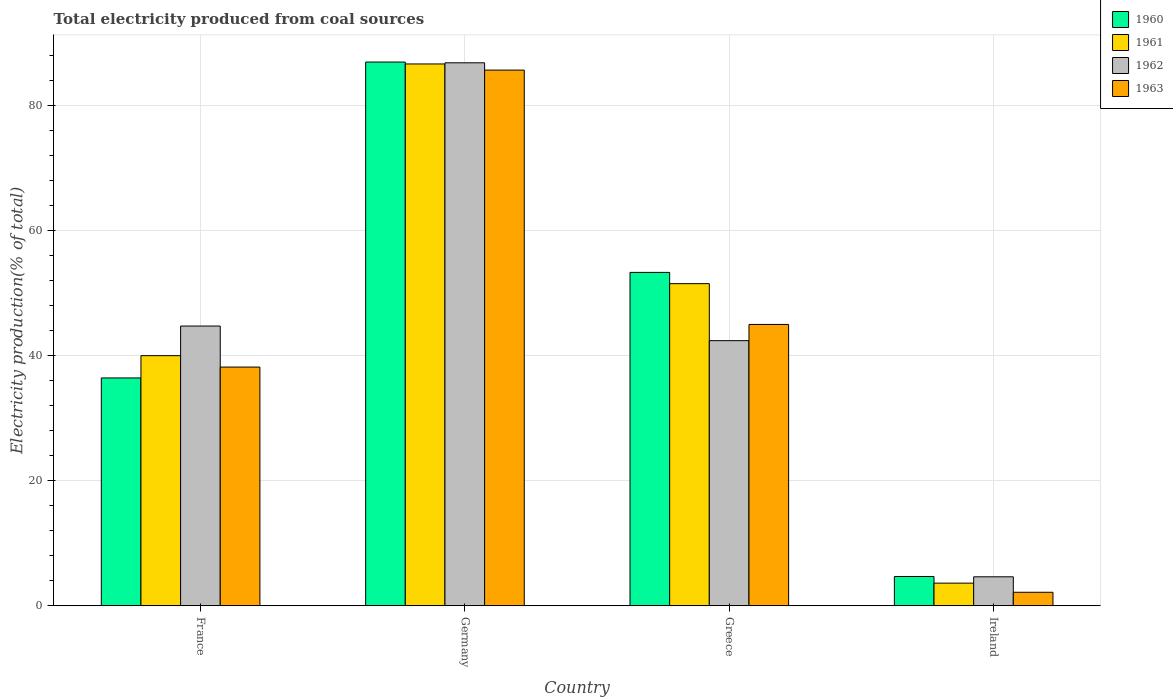How many different coloured bars are there?
Provide a succinct answer. 4. Are the number of bars per tick equal to the number of legend labels?
Give a very brief answer. Yes. Are the number of bars on each tick of the X-axis equal?
Provide a short and direct response. Yes. How many bars are there on the 3rd tick from the left?
Give a very brief answer. 4. What is the label of the 1st group of bars from the left?
Provide a short and direct response. France. In how many cases, is the number of bars for a given country not equal to the number of legend labels?
Ensure brevity in your answer.  0. What is the total electricity produced in 1960 in Germany?
Your answer should be compact. 87.03. Across all countries, what is the maximum total electricity produced in 1960?
Offer a terse response. 87.03. Across all countries, what is the minimum total electricity produced in 1960?
Make the answer very short. 4.69. In which country was the total electricity produced in 1962 minimum?
Provide a succinct answer. Ireland. What is the total total electricity produced in 1963 in the graph?
Ensure brevity in your answer.  171.15. What is the difference between the total electricity produced in 1962 in Greece and that in Ireland?
Offer a very short reply. 37.8. What is the difference between the total electricity produced in 1961 in Greece and the total electricity produced in 1960 in France?
Keep it short and to the point. 15.09. What is the average total electricity produced in 1961 per country?
Offer a very short reply. 45.49. What is the difference between the total electricity produced of/in 1961 and total electricity produced of/in 1963 in France?
Your response must be concise. 1.82. What is the ratio of the total electricity produced in 1961 in Germany to that in Greece?
Make the answer very short. 1.68. Is the total electricity produced in 1961 in Greece less than that in Ireland?
Ensure brevity in your answer.  No. What is the difference between the highest and the second highest total electricity produced in 1961?
Your answer should be very brief. -11.53. What is the difference between the highest and the lowest total electricity produced in 1961?
Your answer should be very brief. 83.1. Is the sum of the total electricity produced in 1960 in Greece and Ireland greater than the maximum total electricity produced in 1963 across all countries?
Ensure brevity in your answer.  No. Is it the case that in every country, the sum of the total electricity produced in 1961 and total electricity produced in 1963 is greater than the sum of total electricity produced in 1962 and total electricity produced in 1960?
Your answer should be very brief. No. What is the difference between two consecutive major ticks on the Y-axis?
Your answer should be compact. 20. Are the values on the major ticks of Y-axis written in scientific E-notation?
Your response must be concise. No. Where does the legend appear in the graph?
Ensure brevity in your answer.  Top right. How many legend labels are there?
Provide a short and direct response. 4. What is the title of the graph?
Your answer should be very brief. Total electricity produced from coal sources. Does "2012" appear as one of the legend labels in the graph?
Keep it short and to the point. No. What is the Electricity production(% of total) of 1960 in France?
Give a very brief answer. 36.47. What is the Electricity production(% of total) of 1961 in France?
Keep it short and to the point. 40.03. What is the Electricity production(% of total) in 1962 in France?
Provide a short and direct response. 44.78. What is the Electricity production(% of total) of 1963 in France?
Your answer should be very brief. 38.21. What is the Electricity production(% of total) of 1960 in Germany?
Give a very brief answer. 87.03. What is the Electricity production(% of total) of 1961 in Germany?
Provide a short and direct response. 86.73. What is the Electricity production(% of total) of 1962 in Germany?
Your answer should be compact. 86.91. What is the Electricity production(% of total) in 1963 in Germany?
Offer a terse response. 85.74. What is the Electricity production(% of total) of 1960 in Greece?
Ensure brevity in your answer.  53.36. What is the Electricity production(% of total) of 1961 in Greece?
Provide a succinct answer. 51.56. What is the Electricity production(% of total) of 1962 in Greece?
Give a very brief answer. 42.44. What is the Electricity production(% of total) in 1963 in Greece?
Ensure brevity in your answer.  45.03. What is the Electricity production(% of total) in 1960 in Ireland?
Offer a very short reply. 4.69. What is the Electricity production(% of total) in 1961 in Ireland?
Offer a terse response. 3.63. What is the Electricity production(% of total) of 1962 in Ireland?
Provide a succinct answer. 4.64. What is the Electricity production(% of total) in 1963 in Ireland?
Ensure brevity in your answer.  2.16. Across all countries, what is the maximum Electricity production(% of total) of 1960?
Offer a terse response. 87.03. Across all countries, what is the maximum Electricity production(% of total) in 1961?
Your response must be concise. 86.73. Across all countries, what is the maximum Electricity production(% of total) in 1962?
Provide a short and direct response. 86.91. Across all countries, what is the maximum Electricity production(% of total) of 1963?
Make the answer very short. 85.74. Across all countries, what is the minimum Electricity production(% of total) of 1960?
Make the answer very short. 4.69. Across all countries, what is the minimum Electricity production(% of total) in 1961?
Offer a terse response. 3.63. Across all countries, what is the minimum Electricity production(% of total) of 1962?
Your answer should be very brief. 4.64. Across all countries, what is the minimum Electricity production(% of total) in 1963?
Ensure brevity in your answer.  2.16. What is the total Electricity production(% of total) in 1960 in the graph?
Your response must be concise. 181.55. What is the total Electricity production(% of total) of 1961 in the graph?
Your answer should be very brief. 181.95. What is the total Electricity production(% of total) of 1962 in the graph?
Your answer should be compact. 178.77. What is the total Electricity production(% of total) in 1963 in the graph?
Offer a very short reply. 171.15. What is the difference between the Electricity production(% of total) of 1960 in France and that in Germany?
Ensure brevity in your answer.  -50.56. What is the difference between the Electricity production(% of total) of 1961 in France and that in Germany?
Your response must be concise. -46.69. What is the difference between the Electricity production(% of total) in 1962 in France and that in Germany?
Offer a very short reply. -42.13. What is the difference between the Electricity production(% of total) of 1963 in France and that in Germany?
Give a very brief answer. -47.53. What is the difference between the Electricity production(% of total) of 1960 in France and that in Greece?
Offer a terse response. -16.89. What is the difference between the Electricity production(% of total) of 1961 in France and that in Greece?
Provide a short and direct response. -11.53. What is the difference between the Electricity production(% of total) in 1962 in France and that in Greece?
Offer a terse response. 2.34. What is the difference between the Electricity production(% of total) of 1963 in France and that in Greece?
Offer a terse response. -6.82. What is the difference between the Electricity production(% of total) of 1960 in France and that in Ireland?
Offer a terse response. 31.78. What is the difference between the Electricity production(% of total) of 1961 in France and that in Ireland?
Your response must be concise. 36.41. What is the difference between the Electricity production(% of total) of 1962 in France and that in Ireland?
Your answer should be compact. 40.14. What is the difference between the Electricity production(% of total) in 1963 in France and that in Ireland?
Provide a succinct answer. 36.05. What is the difference between the Electricity production(% of total) in 1960 in Germany and that in Greece?
Your response must be concise. 33.67. What is the difference between the Electricity production(% of total) in 1961 in Germany and that in Greece?
Keep it short and to the point. 35.16. What is the difference between the Electricity production(% of total) of 1962 in Germany and that in Greece?
Offer a terse response. 44.47. What is the difference between the Electricity production(% of total) in 1963 in Germany and that in Greece?
Offer a very short reply. 40.71. What is the difference between the Electricity production(% of total) of 1960 in Germany and that in Ireland?
Offer a very short reply. 82.34. What is the difference between the Electricity production(% of total) of 1961 in Germany and that in Ireland?
Keep it short and to the point. 83.1. What is the difference between the Electricity production(% of total) in 1962 in Germany and that in Ireland?
Ensure brevity in your answer.  82.27. What is the difference between the Electricity production(% of total) in 1963 in Germany and that in Ireland?
Give a very brief answer. 83.58. What is the difference between the Electricity production(% of total) in 1960 in Greece and that in Ireland?
Your response must be concise. 48.68. What is the difference between the Electricity production(% of total) of 1961 in Greece and that in Ireland?
Provide a succinct answer. 47.93. What is the difference between the Electricity production(% of total) of 1962 in Greece and that in Ireland?
Give a very brief answer. 37.8. What is the difference between the Electricity production(% of total) in 1963 in Greece and that in Ireland?
Provide a short and direct response. 42.87. What is the difference between the Electricity production(% of total) in 1960 in France and the Electricity production(% of total) in 1961 in Germany?
Offer a terse response. -50.26. What is the difference between the Electricity production(% of total) of 1960 in France and the Electricity production(% of total) of 1962 in Germany?
Keep it short and to the point. -50.44. What is the difference between the Electricity production(% of total) of 1960 in France and the Electricity production(% of total) of 1963 in Germany?
Offer a very short reply. -49.27. What is the difference between the Electricity production(% of total) of 1961 in France and the Electricity production(% of total) of 1962 in Germany?
Provide a short and direct response. -46.87. What is the difference between the Electricity production(% of total) of 1961 in France and the Electricity production(% of total) of 1963 in Germany?
Offer a very short reply. -45.71. What is the difference between the Electricity production(% of total) in 1962 in France and the Electricity production(% of total) in 1963 in Germany?
Offer a terse response. -40.97. What is the difference between the Electricity production(% of total) of 1960 in France and the Electricity production(% of total) of 1961 in Greece?
Provide a succinct answer. -15.09. What is the difference between the Electricity production(% of total) of 1960 in France and the Electricity production(% of total) of 1962 in Greece?
Your answer should be compact. -5.97. What is the difference between the Electricity production(% of total) of 1960 in France and the Electricity production(% of total) of 1963 in Greece?
Give a very brief answer. -8.56. What is the difference between the Electricity production(% of total) of 1961 in France and the Electricity production(% of total) of 1962 in Greece?
Provide a short and direct response. -2.41. What is the difference between the Electricity production(% of total) in 1961 in France and the Electricity production(% of total) in 1963 in Greece?
Keep it short and to the point. -5. What is the difference between the Electricity production(% of total) of 1962 in France and the Electricity production(% of total) of 1963 in Greece?
Your response must be concise. -0.25. What is the difference between the Electricity production(% of total) of 1960 in France and the Electricity production(% of total) of 1961 in Ireland?
Provide a short and direct response. 32.84. What is the difference between the Electricity production(% of total) of 1960 in France and the Electricity production(% of total) of 1962 in Ireland?
Keep it short and to the point. 31.83. What is the difference between the Electricity production(% of total) of 1960 in France and the Electricity production(% of total) of 1963 in Ireland?
Your answer should be compact. 34.3. What is the difference between the Electricity production(% of total) of 1961 in France and the Electricity production(% of total) of 1962 in Ireland?
Your response must be concise. 35.39. What is the difference between the Electricity production(% of total) of 1961 in France and the Electricity production(% of total) of 1963 in Ireland?
Your answer should be very brief. 37.87. What is the difference between the Electricity production(% of total) of 1962 in France and the Electricity production(% of total) of 1963 in Ireland?
Offer a very short reply. 42.61. What is the difference between the Electricity production(% of total) of 1960 in Germany and the Electricity production(% of total) of 1961 in Greece?
Offer a terse response. 35.47. What is the difference between the Electricity production(% of total) in 1960 in Germany and the Electricity production(% of total) in 1962 in Greece?
Provide a succinct answer. 44.59. What is the difference between the Electricity production(% of total) of 1960 in Germany and the Electricity production(% of total) of 1963 in Greece?
Keep it short and to the point. 42. What is the difference between the Electricity production(% of total) in 1961 in Germany and the Electricity production(% of total) in 1962 in Greece?
Provide a succinct answer. 44.29. What is the difference between the Electricity production(% of total) of 1961 in Germany and the Electricity production(% of total) of 1963 in Greece?
Ensure brevity in your answer.  41.69. What is the difference between the Electricity production(% of total) in 1962 in Germany and the Electricity production(% of total) in 1963 in Greece?
Provide a short and direct response. 41.88. What is the difference between the Electricity production(% of total) of 1960 in Germany and the Electricity production(% of total) of 1961 in Ireland?
Your answer should be compact. 83.4. What is the difference between the Electricity production(% of total) of 1960 in Germany and the Electricity production(% of total) of 1962 in Ireland?
Offer a very short reply. 82.39. What is the difference between the Electricity production(% of total) in 1960 in Germany and the Electricity production(% of total) in 1963 in Ireland?
Offer a very short reply. 84.86. What is the difference between the Electricity production(% of total) in 1961 in Germany and the Electricity production(% of total) in 1962 in Ireland?
Offer a very short reply. 82.08. What is the difference between the Electricity production(% of total) of 1961 in Germany and the Electricity production(% of total) of 1963 in Ireland?
Keep it short and to the point. 84.56. What is the difference between the Electricity production(% of total) in 1962 in Germany and the Electricity production(% of total) in 1963 in Ireland?
Provide a short and direct response. 84.74. What is the difference between the Electricity production(% of total) of 1960 in Greece and the Electricity production(% of total) of 1961 in Ireland?
Keep it short and to the point. 49.73. What is the difference between the Electricity production(% of total) in 1960 in Greece and the Electricity production(% of total) in 1962 in Ireland?
Offer a very short reply. 48.72. What is the difference between the Electricity production(% of total) in 1960 in Greece and the Electricity production(% of total) in 1963 in Ireland?
Give a very brief answer. 51.2. What is the difference between the Electricity production(% of total) in 1961 in Greece and the Electricity production(% of total) in 1962 in Ireland?
Ensure brevity in your answer.  46.92. What is the difference between the Electricity production(% of total) of 1961 in Greece and the Electricity production(% of total) of 1963 in Ireland?
Your answer should be compact. 49.4. What is the difference between the Electricity production(% of total) in 1962 in Greece and the Electricity production(% of total) in 1963 in Ireland?
Provide a succinct answer. 40.27. What is the average Electricity production(% of total) in 1960 per country?
Keep it short and to the point. 45.39. What is the average Electricity production(% of total) in 1961 per country?
Your answer should be compact. 45.49. What is the average Electricity production(% of total) of 1962 per country?
Give a very brief answer. 44.69. What is the average Electricity production(% of total) of 1963 per country?
Your answer should be compact. 42.79. What is the difference between the Electricity production(% of total) of 1960 and Electricity production(% of total) of 1961 in France?
Offer a terse response. -3.57. What is the difference between the Electricity production(% of total) of 1960 and Electricity production(% of total) of 1962 in France?
Make the answer very short. -8.31. What is the difference between the Electricity production(% of total) of 1960 and Electricity production(% of total) of 1963 in France?
Ensure brevity in your answer.  -1.74. What is the difference between the Electricity production(% of total) of 1961 and Electricity production(% of total) of 1962 in France?
Keep it short and to the point. -4.74. What is the difference between the Electricity production(% of total) in 1961 and Electricity production(% of total) in 1963 in France?
Offer a terse response. 1.82. What is the difference between the Electricity production(% of total) in 1962 and Electricity production(% of total) in 1963 in France?
Your answer should be compact. 6.57. What is the difference between the Electricity production(% of total) in 1960 and Electricity production(% of total) in 1961 in Germany?
Your answer should be very brief. 0.3. What is the difference between the Electricity production(% of total) in 1960 and Electricity production(% of total) in 1962 in Germany?
Offer a very short reply. 0.12. What is the difference between the Electricity production(% of total) in 1960 and Electricity production(% of total) in 1963 in Germany?
Ensure brevity in your answer.  1.29. What is the difference between the Electricity production(% of total) of 1961 and Electricity production(% of total) of 1962 in Germany?
Keep it short and to the point. -0.18. What is the difference between the Electricity production(% of total) in 1961 and Electricity production(% of total) in 1963 in Germany?
Give a very brief answer. 0.98. What is the difference between the Electricity production(% of total) of 1962 and Electricity production(% of total) of 1963 in Germany?
Make the answer very short. 1.17. What is the difference between the Electricity production(% of total) of 1960 and Electricity production(% of total) of 1961 in Greece?
Make the answer very short. 1.8. What is the difference between the Electricity production(% of total) in 1960 and Electricity production(% of total) in 1962 in Greece?
Your answer should be very brief. 10.92. What is the difference between the Electricity production(% of total) of 1960 and Electricity production(% of total) of 1963 in Greece?
Offer a very short reply. 8.33. What is the difference between the Electricity production(% of total) of 1961 and Electricity production(% of total) of 1962 in Greece?
Provide a succinct answer. 9.12. What is the difference between the Electricity production(% of total) of 1961 and Electricity production(% of total) of 1963 in Greece?
Your answer should be compact. 6.53. What is the difference between the Electricity production(% of total) in 1962 and Electricity production(% of total) in 1963 in Greece?
Make the answer very short. -2.59. What is the difference between the Electricity production(% of total) of 1960 and Electricity production(% of total) of 1961 in Ireland?
Offer a terse response. 1.06. What is the difference between the Electricity production(% of total) in 1960 and Electricity production(% of total) in 1962 in Ireland?
Your answer should be compact. 0.05. What is the difference between the Electricity production(% of total) of 1960 and Electricity production(% of total) of 1963 in Ireland?
Ensure brevity in your answer.  2.52. What is the difference between the Electricity production(% of total) of 1961 and Electricity production(% of total) of 1962 in Ireland?
Your answer should be compact. -1.01. What is the difference between the Electricity production(% of total) of 1961 and Electricity production(% of total) of 1963 in Ireland?
Ensure brevity in your answer.  1.46. What is the difference between the Electricity production(% of total) in 1962 and Electricity production(% of total) in 1963 in Ireland?
Give a very brief answer. 2.48. What is the ratio of the Electricity production(% of total) of 1960 in France to that in Germany?
Make the answer very short. 0.42. What is the ratio of the Electricity production(% of total) in 1961 in France to that in Germany?
Provide a succinct answer. 0.46. What is the ratio of the Electricity production(% of total) in 1962 in France to that in Germany?
Keep it short and to the point. 0.52. What is the ratio of the Electricity production(% of total) in 1963 in France to that in Germany?
Your answer should be compact. 0.45. What is the ratio of the Electricity production(% of total) in 1960 in France to that in Greece?
Ensure brevity in your answer.  0.68. What is the ratio of the Electricity production(% of total) in 1961 in France to that in Greece?
Offer a terse response. 0.78. What is the ratio of the Electricity production(% of total) in 1962 in France to that in Greece?
Ensure brevity in your answer.  1.06. What is the ratio of the Electricity production(% of total) of 1963 in France to that in Greece?
Your answer should be compact. 0.85. What is the ratio of the Electricity production(% of total) of 1960 in France to that in Ireland?
Your answer should be very brief. 7.78. What is the ratio of the Electricity production(% of total) in 1961 in France to that in Ireland?
Your answer should be compact. 11.03. What is the ratio of the Electricity production(% of total) of 1962 in France to that in Ireland?
Provide a short and direct response. 9.65. What is the ratio of the Electricity production(% of total) in 1963 in France to that in Ireland?
Keep it short and to the point. 17.65. What is the ratio of the Electricity production(% of total) in 1960 in Germany to that in Greece?
Keep it short and to the point. 1.63. What is the ratio of the Electricity production(% of total) of 1961 in Germany to that in Greece?
Offer a very short reply. 1.68. What is the ratio of the Electricity production(% of total) in 1962 in Germany to that in Greece?
Ensure brevity in your answer.  2.05. What is the ratio of the Electricity production(% of total) of 1963 in Germany to that in Greece?
Your response must be concise. 1.9. What is the ratio of the Electricity production(% of total) of 1960 in Germany to that in Ireland?
Give a very brief answer. 18.57. What is the ratio of the Electricity production(% of total) of 1961 in Germany to that in Ireland?
Provide a short and direct response. 23.9. What is the ratio of the Electricity production(% of total) in 1962 in Germany to that in Ireland?
Make the answer very short. 18.73. What is the ratio of the Electricity production(% of total) in 1963 in Germany to that in Ireland?
Offer a terse response. 39.6. What is the ratio of the Electricity production(% of total) of 1960 in Greece to that in Ireland?
Make the answer very short. 11.39. What is the ratio of the Electricity production(% of total) in 1961 in Greece to that in Ireland?
Give a very brief answer. 14.21. What is the ratio of the Electricity production(% of total) of 1962 in Greece to that in Ireland?
Offer a terse response. 9.14. What is the ratio of the Electricity production(% of total) of 1963 in Greece to that in Ireland?
Offer a very short reply. 20.8. What is the difference between the highest and the second highest Electricity production(% of total) in 1960?
Offer a very short reply. 33.67. What is the difference between the highest and the second highest Electricity production(% of total) in 1961?
Keep it short and to the point. 35.16. What is the difference between the highest and the second highest Electricity production(% of total) of 1962?
Offer a terse response. 42.13. What is the difference between the highest and the second highest Electricity production(% of total) in 1963?
Provide a succinct answer. 40.71. What is the difference between the highest and the lowest Electricity production(% of total) of 1960?
Offer a very short reply. 82.34. What is the difference between the highest and the lowest Electricity production(% of total) of 1961?
Provide a short and direct response. 83.1. What is the difference between the highest and the lowest Electricity production(% of total) of 1962?
Offer a very short reply. 82.27. What is the difference between the highest and the lowest Electricity production(% of total) of 1963?
Keep it short and to the point. 83.58. 